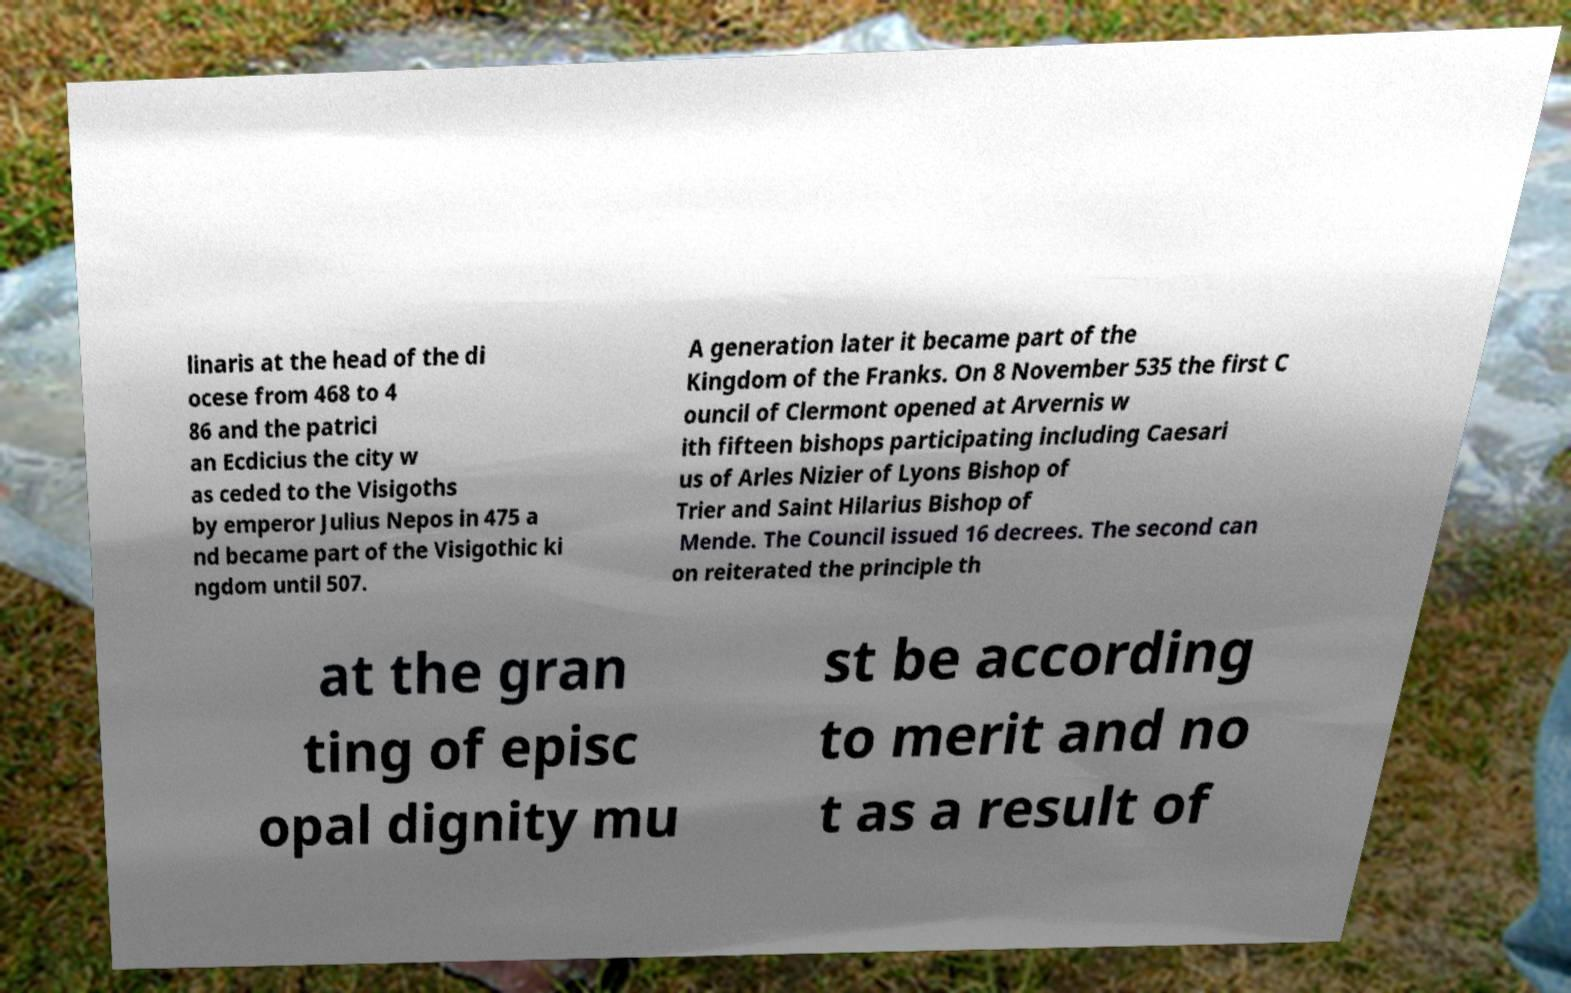Please read and relay the text visible in this image. What does it say? linaris at the head of the di ocese from 468 to 4 86 and the patrici an Ecdicius the city w as ceded to the Visigoths by emperor Julius Nepos in 475 a nd became part of the Visigothic ki ngdom until 507. A generation later it became part of the Kingdom of the Franks. On 8 November 535 the first C ouncil of Clermont opened at Arvernis w ith fifteen bishops participating including Caesari us of Arles Nizier of Lyons Bishop of Trier and Saint Hilarius Bishop of Mende. The Council issued 16 decrees. The second can on reiterated the principle th at the gran ting of episc opal dignity mu st be according to merit and no t as a result of 